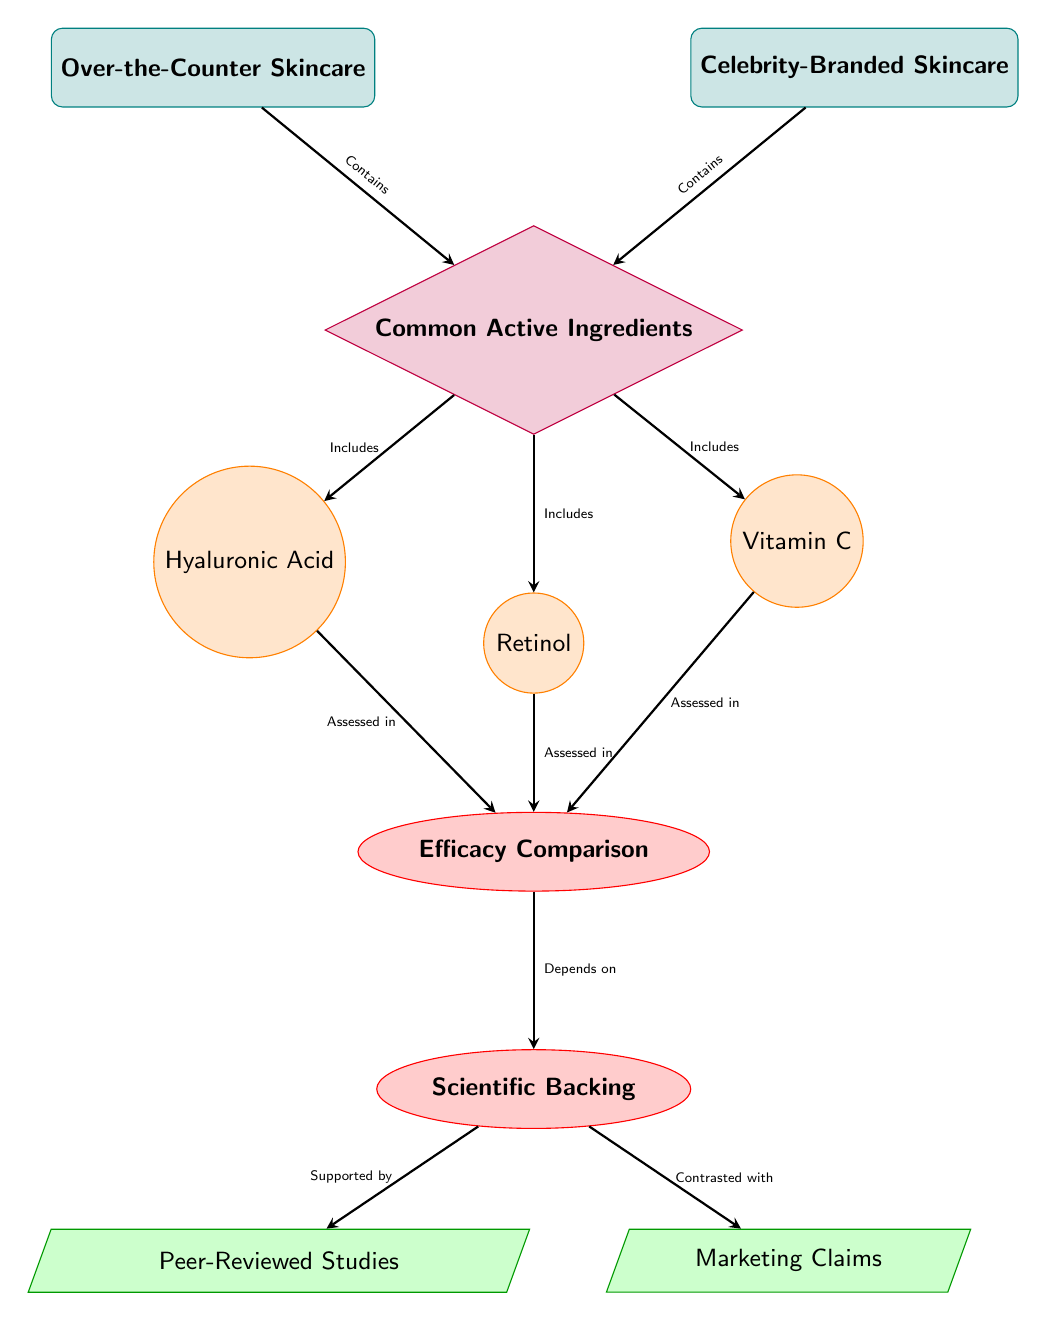What's the category of the left node? The left node represents the skincare products available over the counter, and it is labeled as "Over-the-Counter Skincare."
Answer: Over-the-Counter Skincare How many common active ingredients are listed in the diagram? There are three active ingredients depicted below the common active ingredients node: Hyaluronic Acid, Retinol, and Vitamin C.
Answer: 3 What type of ingredient is Hyaluronic Acid classified as? Hyaluronic Acid is represented as a circle in the diagram, indicating it is classified as an ingredient.
Answer: Ingredient What does the efficacy comparison depend on? According to the diagram, the efficacy comparison is dependent on scientific backing, which is noted to the right of the efficacy comparison node.
Answer: Scientific Backing What are the two types of support for scientific backing? The diagram shows two support types for scientific backing: Peer-Reviewed Studies on the left and Marketing Claims on the right.
Answer: Peer-Reviewed Studies and Marketing Claims Which skincare line has the node "Common Active Ingredients" connected to it? Both "Over-the-Counter Skincare" and "Celebrity-Branded Skincare" have arrows indicating they contain common active ingredients, so both are connected to this node.
Answer: Both Which ingredient is assessed in the efficacy comparison? All three ingredients: Hyaluronic Acid, Retinol, and Vitamin C are assessed in the efficacy comparison as shown by arrows leading to the efficacy comparison node.
Answer: All three ingredients What shape represents the Efficacy Comparison node? The Efficacy Comparison node is shaped like an ellipse, indicating its significance in the assessment of the effectiveness of the products.
Answer: Ellipse What color are the ingredients represented in the diagram? The ingredients, including Hyaluronic Acid, Retinol, and Vitamin C, are shown in an orange color, indicating their categorical representation.
Answer: Orange 